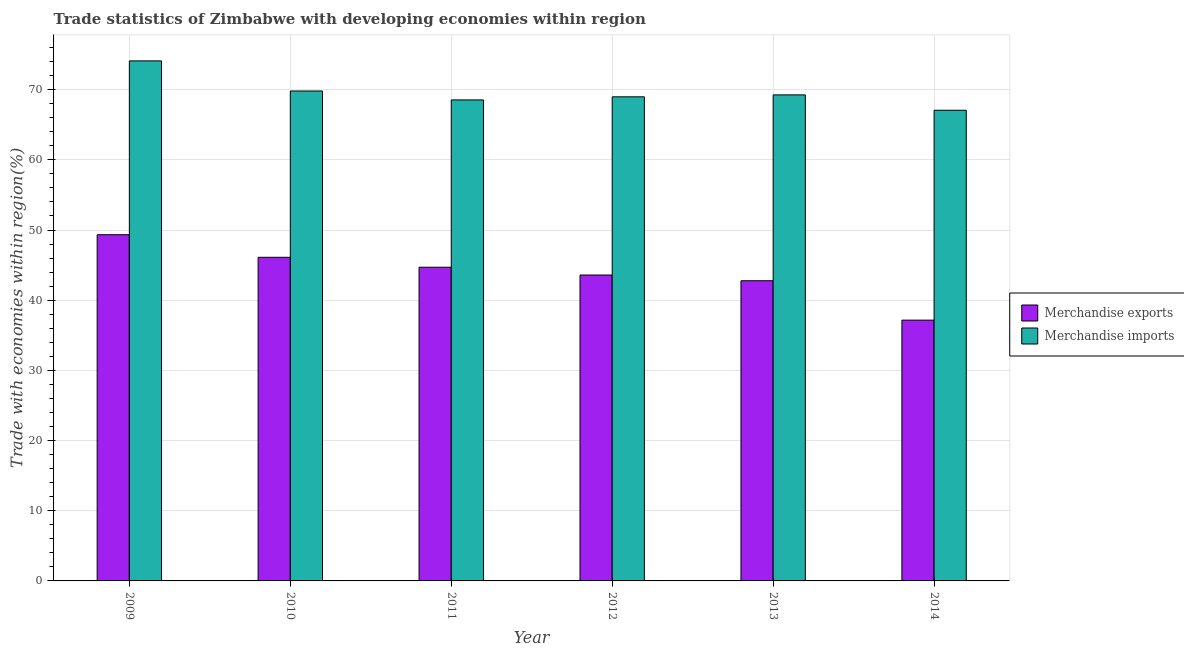Are the number of bars per tick equal to the number of legend labels?
Give a very brief answer. Yes. Are the number of bars on each tick of the X-axis equal?
Provide a short and direct response. Yes. What is the label of the 5th group of bars from the left?
Make the answer very short. 2013. In how many cases, is the number of bars for a given year not equal to the number of legend labels?
Give a very brief answer. 0. What is the merchandise imports in 2014?
Ensure brevity in your answer.  67.07. Across all years, what is the maximum merchandise exports?
Offer a very short reply. 49.33. Across all years, what is the minimum merchandise exports?
Your answer should be very brief. 37.16. In which year was the merchandise imports maximum?
Make the answer very short. 2009. What is the total merchandise exports in the graph?
Your response must be concise. 263.67. What is the difference between the merchandise imports in 2012 and that in 2013?
Offer a very short reply. -0.27. What is the difference between the merchandise exports in 2012 and the merchandise imports in 2014?
Your answer should be very brief. 6.43. What is the average merchandise exports per year?
Provide a succinct answer. 43.94. In the year 2011, what is the difference between the merchandise imports and merchandise exports?
Provide a succinct answer. 0. In how many years, is the merchandise imports greater than 2 %?
Offer a terse response. 6. What is the ratio of the merchandise exports in 2010 to that in 2012?
Keep it short and to the point. 1.06. What is the difference between the highest and the second highest merchandise imports?
Keep it short and to the point. 4.29. What is the difference between the highest and the lowest merchandise imports?
Offer a terse response. 7.03. Is the sum of the merchandise exports in 2010 and 2012 greater than the maximum merchandise imports across all years?
Keep it short and to the point. Yes. What does the 2nd bar from the left in 2010 represents?
Your response must be concise. Merchandise imports. How many bars are there?
Your response must be concise. 12. Are all the bars in the graph horizontal?
Give a very brief answer. No. What is the difference between two consecutive major ticks on the Y-axis?
Ensure brevity in your answer.  10. Does the graph contain any zero values?
Ensure brevity in your answer.  No. How many legend labels are there?
Your answer should be compact. 2. How are the legend labels stacked?
Provide a short and direct response. Vertical. What is the title of the graph?
Provide a succinct answer. Trade statistics of Zimbabwe with developing economies within region. Does "Foreign liabilities" appear as one of the legend labels in the graph?
Your response must be concise. No. What is the label or title of the X-axis?
Give a very brief answer. Year. What is the label or title of the Y-axis?
Your response must be concise. Trade with economies within region(%). What is the Trade with economies within region(%) in Merchandise exports in 2009?
Provide a succinct answer. 49.33. What is the Trade with economies within region(%) in Merchandise imports in 2009?
Keep it short and to the point. 74.1. What is the Trade with economies within region(%) of Merchandise exports in 2010?
Provide a succinct answer. 46.11. What is the Trade with economies within region(%) of Merchandise imports in 2010?
Your response must be concise. 69.81. What is the Trade with economies within region(%) in Merchandise exports in 2011?
Give a very brief answer. 44.7. What is the Trade with economies within region(%) in Merchandise imports in 2011?
Ensure brevity in your answer.  68.54. What is the Trade with economies within region(%) of Merchandise exports in 2012?
Provide a succinct answer. 43.59. What is the Trade with economies within region(%) in Merchandise imports in 2012?
Ensure brevity in your answer.  68.98. What is the Trade with economies within region(%) in Merchandise exports in 2013?
Offer a very short reply. 42.77. What is the Trade with economies within region(%) in Merchandise imports in 2013?
Your response must be concise. 69.26. What is the Trade with economies within region(%) in Merchandise exports in 2014?
Ensure brevity in your answer.  37.16. What is the Trade with economies within region(%) of Merchandise imports in 2014?
Ensure brevity in your answer.  67.07. Across all years, what is the maximum Trade with economies within region(%) of Merchandise exports?
Ensure brevity in your answer.  49.33. Across all years, what is the maximum Trade with economies within region(%) in Merchandise imports?
Your answer should be compact. 74.1. Across all years, what is the minimum Trade with economies within region(%) in Merchandise exports?
Keep it short and to the point. 37.16. Across all years, what is the minimum Trade with economies within region(%) in Merchandise imports?
Provide a succinct answer. 67.07. What is the total Trade with economies within region(%) in Merchandise exports in the graph?
Your answer should be very brief. 263.67. What is the total Trade with economies within region(%) of Merchandise imports in the graph?
Provide a short and direct response. 417.77. What is the difference between the Trade with economies within region(%) in Merchandise exports in 2009 and that in 2010?
Keep it short and to the point. 3.22. What is the difference between the Trade with economies within region(%) of Merchandise imports in 2009 and that in 2010?
Give a very brief answer. 4.29. What is the difference between the Trade with economies within region(%) of Merchandise exports in 2009 and that in 2011?
Your response must be concise. 4.63. What is the difference between the Trade with economies within region(%) in Merchandise imports in 2009 and that in 2011?
Your response must be concise. 5.56. What is the difference between the Trade with economies within region(%) in Merchandise exports in 2009 and that in 2012?
Make the answer very short. 5.74. What is the difference between the Trade with economies within region(%) in Merchandise imports in 2009 and that in 2012?
Your response must be concise. 5.12. What is the difference between the Trade with economies within region(%) of Merchandise exports in 2009 and that in 2013?
Provide a short and direct response. 6.56. What is the difference between the Trade with economies within region(%) in Merchandise imports in 2009 and that in 2013?
Your answer should be very brief. 4.85. What is the difference between the Trade with economies within region(%) in Merchandise exports in 2009 and that in 2014?
Offer a very short reply. 12.17. What is the difference between the Trade with economies within region(%) in Merchandise imports in 2009 and that in 2014?
Your answer should be compact. 7.03. What is the difference between the Trade with economies within region(%) of Merchandise exports in 2010 and that in 2011?
Offer a very short reply. 1.41. What is the difference between the Trade with economies within region(%) in Merchandise imports in 2010 and that in 2011?
Give a very brief answer. 1.27. What is the difference between the Trade with economies within region(%) of Merchandise exports in 2010 and that in 2012?
Your answer should be very brief. 2.53. What is the difference between the Trade with economies within region(%) in Merchandise imports in 2010 and that in 2012?
Make the answer very short. 0.83. What is the difference between the Trade with economies within region(%) of Merchandise exports in 2010 and that in 2013?
Provide a succinct answer. 3.34. What is the difference between the Trade with economies within region(%) of Merchandise imports in 2010 and that in 2013?
Provide a succinct answer. 0.55. What is the difference between the Trade with economies within region(%) in Merchandise exports in 2010 and that in 2014?
Offer a terse response. 8.95. What is the difference between the Trade with economies within region(%) in Merchandise imports in 2010 and that in 2014?
Provide a succinct answer. 2.74. What is the difference between the Trade with economies within region(%) in Merchandise exports in 2011 and that in 2012?
Your answer should be very brief. 1.11. What is the difference between the Trade with economies within region(%) of Merchandise imports in 2011 and that in 2012?
Offer a very short reply. -0.44. What is the difference between the Trade with economies within region(%) in Merchandise exports in 2011 and that in 2013?
Your answer should be compact. 1.93. What is the difference between the Trade with economies within region(%) of Merchandise imports in 2011 and that in 2013?
Offer a very short reply. -0.72. What is the difference between the Trade with economies within region(%) of Merchandise exports in 2011 and that in 2014?
Give a very brief answer. 7.54. What is the difference between the Trade with economies within region(%) of Merchandise imports in 2011 and that in 2014?
Offer a terse response. 1.47. What is the difference between the Trade with economies within region(%) of Merchandise exports in 2012 and that in 2013?
Give a very brief answer. 0.82. What is the difference between the Trade with economies within region(%) of Merchandise imports in 2012 and that in 2013?
Offer a very short reply. -0.27. What is the difference between the Trade with economies within region(%) of Merchandise exports in 2012 and that in 2014?
Your answer should be compact. 6.43. What is the difference between the Trade with economies within region(%) of Merchandise imports in 2012 and that in 2014?
Your answer should be very brief. 1.91. What is the difference between the Trade with economies within region(%) in Merchandise exports in 2013 and that in 2014?
Your response must be concise. 5.61. What is the difference between the Trade with economies within region(%) in Merchandise imports in 2013 and that in 2014?
Your response must be concise. 2.19. What is the difference between the Trade with economies within region(%) of Merchandise exports in 2009 and the Trade with economies within region(%) of Merchandise imports in 2010?
Make the answer very short. -20.48. What is the difference between the Trade with economies within region(%) in Merchandise exports in 2009 and the Trade with economies within region(%) in Merchandise imports in 2011?
Offer a very short reply. -19.21. What is the difference between the Trade with economies within region(%) in Merchandise exports in 2009 and the Trade with economies within region(%) in Merchandise imports in 2012?
Your answer should be compact. -19.65. What is the difference between the Trade with economies within region(%) of Merchandise exports in 2009 and the Trade with economies within region(%) of Merchandise imports in 2013?
Keep it short and to the point. -19.93. What is the difference between the Trade with economies within region(%) in Merchandise exports in 2009 and the Trade with economies within region(%) in Merchandise imports in 2014?
Offer a terse response. -17.74. What is the difference between the Trade with economies within region(%) in Merchandise exports in 2010 and the Trade with economies within region(%) in Merchandise imports in 2011?
Provide a short and direct response. -22.43. What is the difference between the Trade with economies within region(%) in Merchandise exports in 2010 and the Trade with economies within region(%) in Merchandise imports in 2012?
Your answer should be compact. -22.87. What is the difference between the Trade with economies within region(%) of Merchandise exports in 2010 and the Trade with economies within region(%) of Merchandise imports in 2013?
Make the answer very short. -23.14. What is the difference between the Trade with economies within region(%) of Merchandise exports in 2010 and the Trade with economies within region(%) of Merchandise imports in 2014?
Your answer should be very brief. -20.96. What is the difference between the Trade with economies within region(%) of Merchandise exports in 2011 and the Trade with economies within region(%) of Merchandise imports in 2012?
Keep it short and to the point. -24.28. What is the difference between the Trade with economies within region(%) in Merchandise exports in 2011 and the Trade with economies within region(%) in Merchandise imports in 2013?
Give a very brief answer. -24.56. What is the difference between the Trade with economies within region(%) in Merchandise exports in 2011 and the Trade with economies within region(%) in Merchandise imports in 2014?
Offer a very short reply. -22.37. What is the difference between the Trade with economies within region(%) of Merchandise exports in 2012 and the Trade with economies within region(%) of Merchandise imports in 2013?
Provide a succinct answer. -25.67. What is the difference between the Trade with economies within region(%) in Merchandise exports in 2012 and the Trade with economies within region(%) in Merchandise imports in 2014?
Provide a short and direct response. -23.48. What is the difference between the Trade with economies within region(%) of Merchandise exports in 2013 and the Trade with economies within region(%) of Merchandise imports in 2014?
Your answer should be compact. -24.3. What is the average Trade with economies within region(%) of Merchandise exports per year?
Ensure brevity in your answer.  43.94. What is the average Trade with economies within region(%) in Merchandise imports per year?
Your response must be concise. 69.63. In the year 2009, what is the difference between the Trade with economies within region(%) of Merchandise exports and Trade with economies within region(%) of Merchandise imports?
Ensure brevity in your answer.  -24.77. In the year 2010, what is the difference between the Trade with economies within region(%) in Merchandise exports and Trade with economies within region(%) in Merchandise imports?
Make the answer very short. -23.7. In the year 2011, what is the difference between the Trade with economies within region(%) in Merchandise exports and Trade with economies within region(%) in Merchandise imports?
Offer a very short reply. -23.84. In the year 2012, what is the difference between the Trade with economies within region(%) of Merchandise exports and Trade with economies within region(%) of Merchandise imports?
Offer a very short reply. -25.39. In the year 2013, what is the difference between the Trade with economies within region(%) of Merchandise exports and Trade with economies within region(%) of Merchandise imports?
Keep it short and to the point. -26.48. In the year 2014, what is the difference between the Trade with economies within region(%) in Merchandise exports and Trade with economies within region(%) in Merchandise imports?
Ensure brevity in your answer.  -29.91. What is the ratio of the Trade with economies within region(%) of Merchandise exports in 2009 to that in 2010?
Ensure brevity in your answer.  1.07. What is the ratio of the Trade with economies within region(%) of Merchandise imports in 2009 to that in 2010?
Your answer should be very brief. 1.06. What is the ratio of the Trade with economies within region(%) of Merchandise exports in 2009 to that in 2011?
Provide a short and direct response. 1.1. What is the ratio of the Trade with economies within region(%) in Merchandise imports in 2009 to that in 2011?
Ensure brevity in your answer.  1.08. What is the ratio of the Trade with economies within region(%) of Merchandise exports in 2009 to that in 2012?
Make the answer very short. 1.13. What is the ratio of the Trade with economies within region(%) in Merchandise imports in 2009 to that in 2012?
Give a very brief answer. 1.07. What is the ratio of the Trade with economies within region(%) in Merchandise exports in 2009 to that in 2013?
Ensure brevity in your answer.  1.15. What is the ratio of the Trade with economies within region(%) in Merchandise imports in 2009 to that in 2013?
Offer a very short reply. 1.07. What is the ratio of the Trade with economies within region(%) in Merchandise exports in 2009 to that in 2014?
Offer a very short reply. 1.33. What is the ratio of the Trade with economies within region(%) in Merchandise imports in 2009 to that in 2014?
Ensure brevity in your answer.  1.1. What is the ratio of the Trade with economies within region(%) of Merchandise exports in 2010 to that in 2011?
Provide a succinct answer. 1.03. What is the ratio of the Trade with economies within region(%) of Merchandise imports in 2010 to that in 2011?
Offer a very short reply. 1.02. What is the ratio of the Trade with economies within region(%) of Merchandise exports in 2010 to that in 2012?
Provide a succinct answer. 1.06. What is the ratio of the Trade with economies within region(%) in Merchandise imports in 2010 to that in 2012?
Make the answer very short. 1.01. What is the ratio of the Trade with economies within region(%) in Merchandise exports in 2010 to that in 2013?
Provide a short and direct response. 1.08. What is the ratio of the Trade with economies within region(%) of Merchandise exports in 2010 to that in 2014?
Keep it short and to the point. 1.24. What is the ratio of the Trade with economies within region(%) in Merchandise imports in 2010 to that in 2014?
Your answer should be very brief. 1.04. What is the ratio of the Trade with economies within region(%) of Merchandise exports in 2011 to that in 2012?
Keep it short and to the point. 1.03. What is the ratio of the Trade with economies within region(%) in Merchandise exports in 2011 to that in 2013?
Your answer should be very brief. 1.04. What is the ratio of the Trade with economies within region(%) in Merchandise imports in 2011 to that in 2013?
Your answer should be very brief. 0.99. What is the ratio of the Trade with economies within region(%) in Merchandise exports in 2011 to that in 2014?
Provide a short and direct response. 1.2. What is the ratio of the Trade with economies within region(%) of Merchandise imports in 2011 to that in 2014?
Your answer should be compact. 1.02. What is the ratio of the Trade with economies within region(%) of Merchandise exports in 2012 to that in 2013?
Your answer should be compact. 1.02. What is the ratio of the Trade with economies within region(%) in Merchandise imports in 2012 to that in 2013?
Offer a very short reply. 1. What is the ratio of the Trade with economies within region(%) of Merchandise exports in 2012 to that in 2014?
Your response must be concise. 1.17. What is the ratio of the Trade with economies within region(%) of Merchandise imports in 2012 to that in 2014?
Ensure brevity in your answer.  1.03. What is the ratio of the Trade with economies within region(%) in Merchandise exports in 2013 to that in 2014?
Your answer should be compact. 1.15. What is the ratio of the Trade with economies within region(%) of Merchandise imports in 2013 to that in 2014?
Your answer should be compact. 1.03. What is the difference between the highest and the second highest Trade with economies within region(%) in Merchandise exports?
Make the answer very short. 3.22. What is the difference between the highest and the second highest Trade with economies within region(%) of Merchandise imports?
Your answer should be compact. 4.29. What is the difference between the highest and the lowest Trade with economies within region(%) in Merchandise exports?
Provide a short and direct response. 12.17. What is the difference between the highest and the lowest Trade with economies within region(%) in Merchandise imports?
Ensure brevity in your answer.  7.03. 